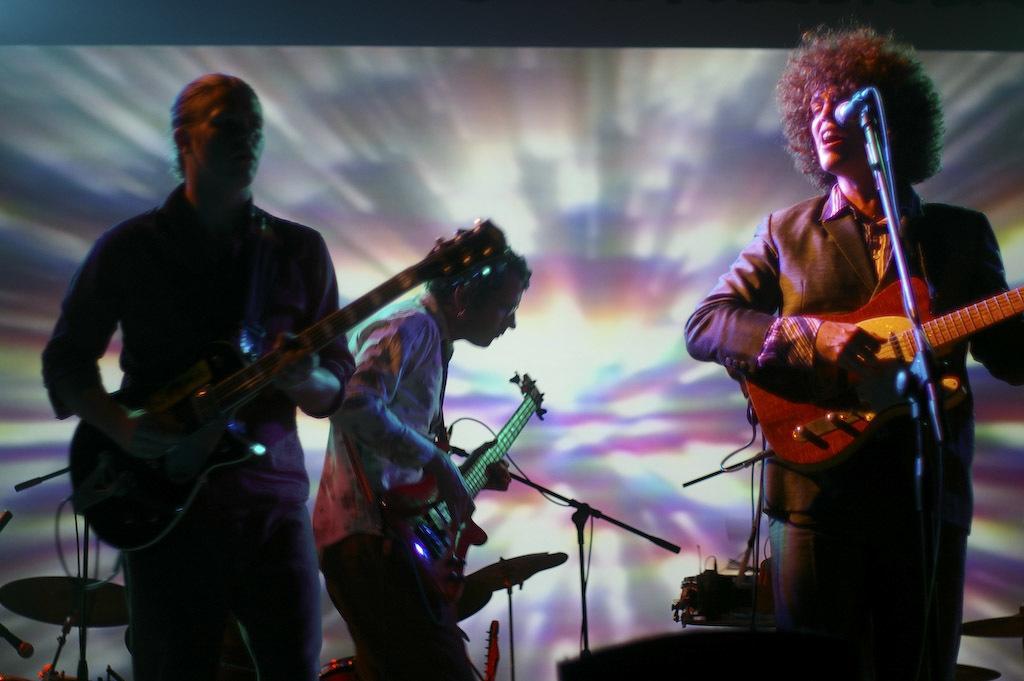How would you summarize this image in a sentence or two? In this picture we can see three men holding guitars in their hands and playing it and here this person is singing on mic and in background we can see piano, drums. 